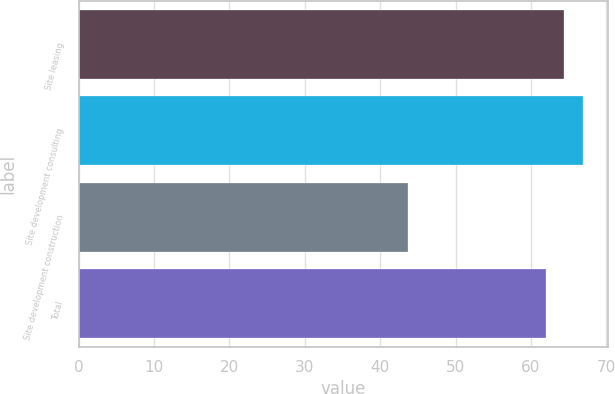Convert chart. <chart><loc_0><loc_0><loc_500><loc_500><bar_chart><fcel>Site leasing<fcel>Site development consulting<fcel>Site development construction<fcel>Total<nl><fcel>64.32<fcel>66.9<fcel>43.7<fcel>62<nl></chart> 